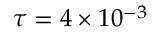<formula> <loc_0><loc_0><loc_500><loc_500>\tau = 4 \times 1 0 ^ { - 3 }</formula> 